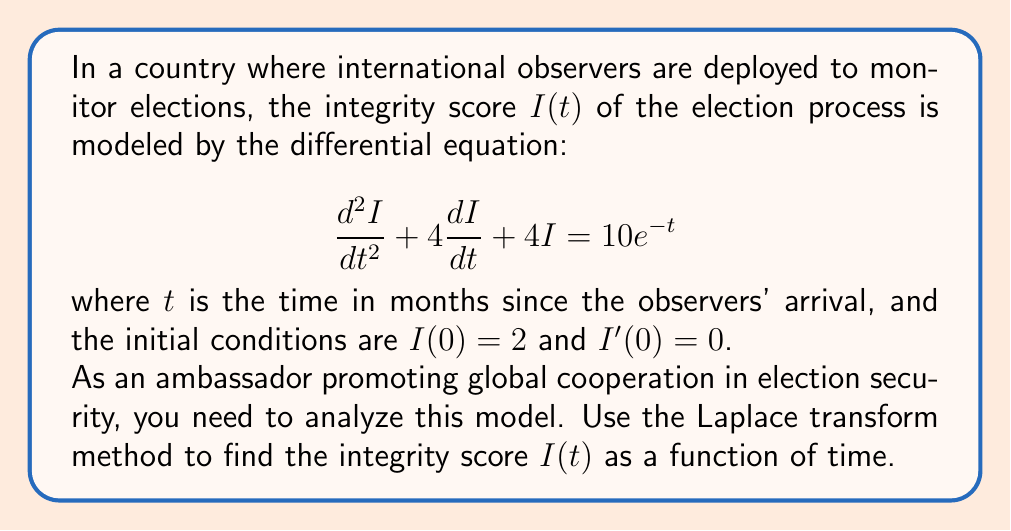Show me your answer to this math problem. Let's solve this problem step by step using the Laplace transform method:

1) First, we take the Laplace transform of both sides of the differential equation:

   $\mathcal{L}\{I''(t) + 4I'(t) + 4I(t)\} = \mathcal{L}\{10e^{-t}\}$

2) Using the properties of Laplace transforms:

   $(s^2\mathcal{L}\{I(t)\} - sI(0) - I'(0)) + 4(s\mathcal{L}\{I(t)\} - I(0)) + 4\mathcal{L}\{I(t)\} = \frac{10}{s+1}$

3) Let $\mathcal{L}\{I(t)\} = Y(s)$. Substituting the initial conditions:

   $(s^2Y(s) - 2s - 0) + 4(sY(s) - 2) + 4Y(s) = \frac{10}{s+1}$

4) Simplify:

   $s^2Y(s) + 4sY(s) + 4Y(s) - 2s - 8 = \frac{10}{s+1}$

   $(s^2 + 4s + 4)Y(s) = \frac{10}{s+1} + 2s + 8$

5) Solve for $Y(s)$:

   $Y(s) = \frac{10}{(s+1)(s^2 + 4s + 4)} + \frac{2s + 8}{s^2 + 4s + 4}$

6) Decompose into partial fractions:

   $Y(s) = \frac{A}{s+1} + \frac{B}{s+2} + \frac{C}{(s+2)^2} + \frac{2s + 8}{(s+2)^2}$

   Where $A = 2$, $B = -2$, and $C = 2$

7) Take the inverse Laplace transform:

   $I(t) = 2e^{-t} - 2te^{-2t} + 2e^{-2t} + (2t + 2)e^{-2t}$

8) Simplify:

   $I(t) = 2e^{-t} + (4 - 2t)e^{-2t}$

This is the final expression for the integrity score $I(t)$ as a function of time $t$.
Answer: $I(t) = 2e^{-t} + (4 - 2t)e^{-2t}$ 